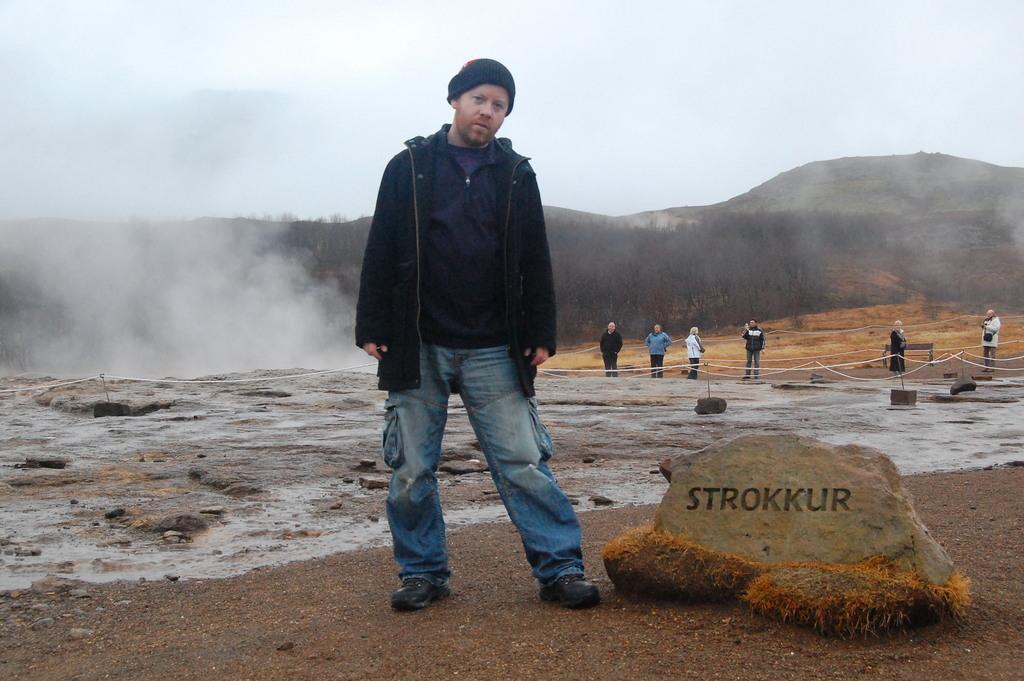Can you describe this image briefly? In the foreground of the picture there is a person standing, beside him there is a stone. In the center of the picture there are stones, fencing, ash, smoke and people. In the background there are trees, hill and sky. 